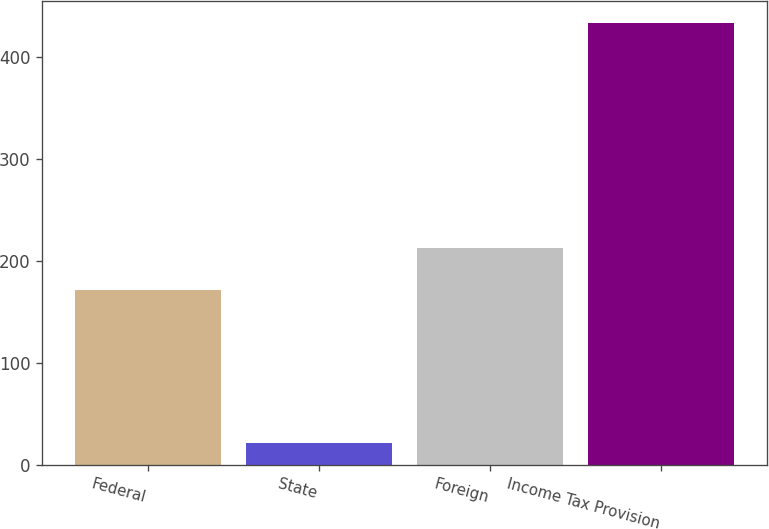Convert chart. <chart><loc_0><loc_0><loc_500><loc_500><bar_chart><fcel>Federal<fcel>State<fcel>Foreign<fcel>Income Tax Provision<nl><fcel>171<fcel>21.2<fcel>212.14<fcel>432.6<nl></chart> 